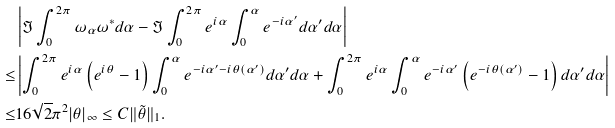<formula> <loc_0><loc_0><loc_500><loc_500>& \left | \Im \int _ { 0 } ^ { 2 \pi } \omega _ { \alpha } \omega ^ { \ast } d \alpha - \Im \int _ { 0 } ^ { 2 \pi } e ^ { i \alpha } \int _ { 0 } ^ { \alpha } e ^ { - i \alpha ^ { \prime } } d \alpha ^ { \prime } d \alpha \right | \\ \leq & \left | \int _ { 0 } ^ { 2 \pi } e ^ { i \alpha } \left ( e ^ { i \theta } - 1 \right ) \int _ { 0 } ^ { \alpha } e ^ { - i \alpha ^ { \prime } - i \theta ( \alpha ^ { \prime } ) } d \alpha ^ { \prime } d \alpha + \int _ { 0 } ^ { 2 \pi } e ^ { i \alpha } \int _ { 0 } ^ { \alpha } e ^ { - i \alpha ^ { \prime } } \left ( e ^ { - i \theta ( \alpha ^ { \prime } ) } - 1 \right ) d \alpha ^ { \prime } d \alpha \right | \\ \leq & 1 6 \sqrt { 2 } \pi ^ { 2 } | \theta | _ { \infty } \leq C \| \tilde { \theta } \| _ { 1 } .</formula> 